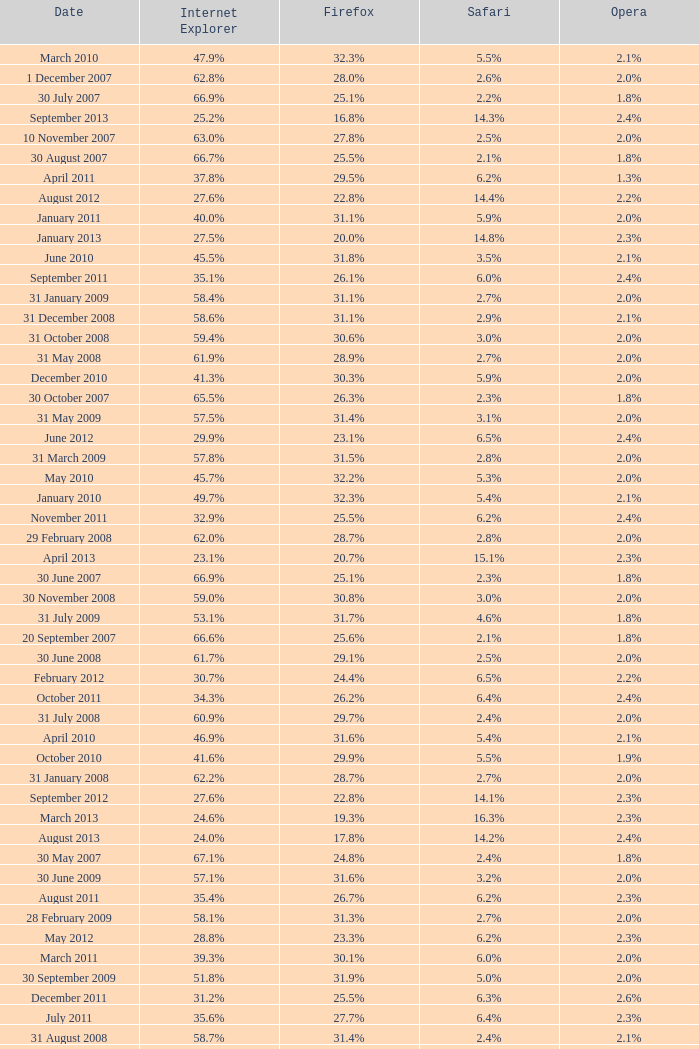What is the safari value with a 2.4% opera and 29.9% internet explorer? 6.5%. 